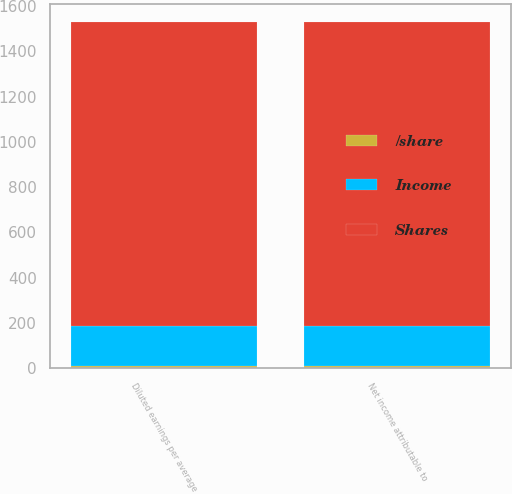<chart> <loc_0><loc_0><loc_500><loc_500><stacked_bar_chart><ecel><fcel>Net income attributable to<fcel>Diluted earnings per average<nl><fcel>Shares<fcel>1346.4<fcel>1346.4<nl><fcel>Income<fcel>177.4<fcel>178.4<nl><fcel>/share<fcel>7.59<fcel>7.55<nl></chart> 